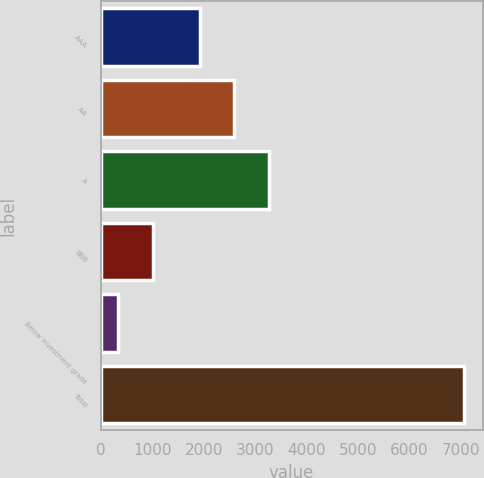Convert chart to OTSL. <chart><loc_0><loc_0><loc_500><loc_500><bar_chart><fcel>AAA<fcel>AA<fcel>A<fcel>BBB<fcel>Below investment grade<fcel>Total<nl><fcel>1922<fcel>2596<fcel>3270<fcel>1005<fcel>331<fcel>7071<nl></chart> 